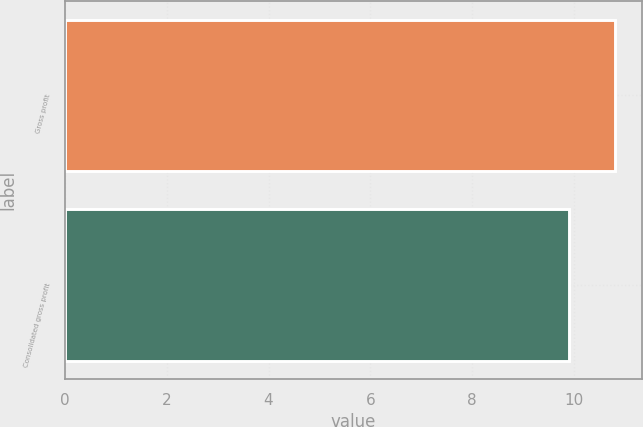<chart> <loc_0><loc_0><loc_500><loc_500><bar_chart><fcel>Gross profit<fcel>Consolidated gross profit<nl><fcel>10.8<fcel>9.9<nl></chart> 